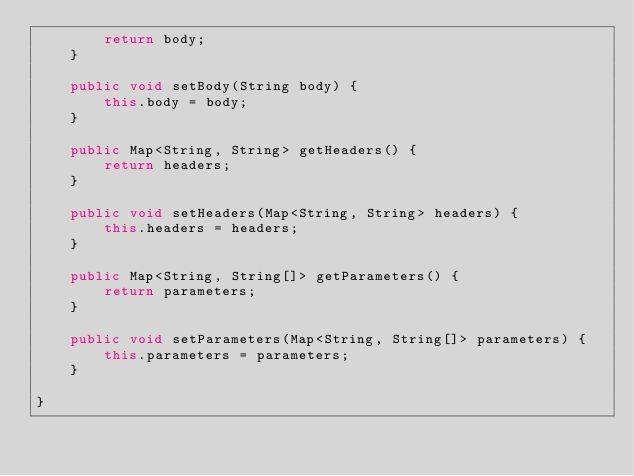Convert code to text. <code><loc_0><loc_0><loc_500><loc_500><_Java_>        return body;
    }

    public void setBody(String body) {
        this.body = body;
    }

    public Map<String, String> getHeaders() {
        return headers;
    }

    public void setHeaders(Map<String, String> headers) {
        this.headers = headers;
    }

    public Map<String, String[]> getParameters() {
        return parameters;
    }

    public void setParameters(Map<String, String[]> parameters) {
        this.parameters = parameters;
    }

}
</code> 